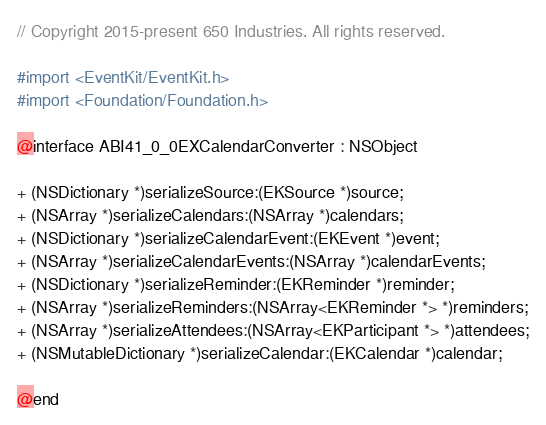Convert code to text. <code><loc_0><loc_0><loc_500><loc_500><_C_>// Copyright 2015-present 650 Industries. All rights reserved.

#import <EventKit/EventKit.h>
#import <Foundation/Foundation.h>

@interface ABI41_0_0EXCalendarConverter : NSObject

+ (NSDictionary *)serializeSource:(EKSource *)source;
+ (NSArray *)serializeCalendars:(NSArray *)calendars;
+ (NSDictionary *)serializeCalendarEvent:(EKEvent *)event;
+ (NSArray *)serializeCalendarEvents:(NSArray *)calendarEvents;
+ (NSDictionary *)serializeReminder:(EKReminder *)reminder;
+ (NSArray *)serializeReminders:(NSArray<EKReminder *> *)reminders;
+ (NSArray *)serializeAttendees:(NSArray<EKParticipant *> *)attendees;
+ (NSMutableDictionary *)serializeCalendar:(EKCalendar *)calendar;

@end
</code> 